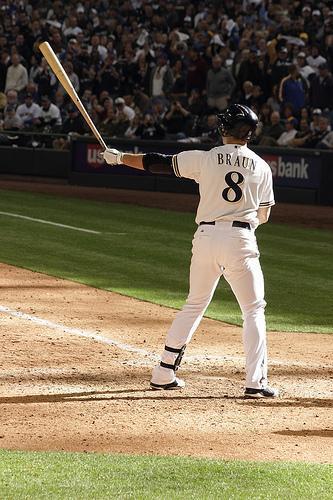How many people are standing at home plate?
Give a very brief answer. 1. 